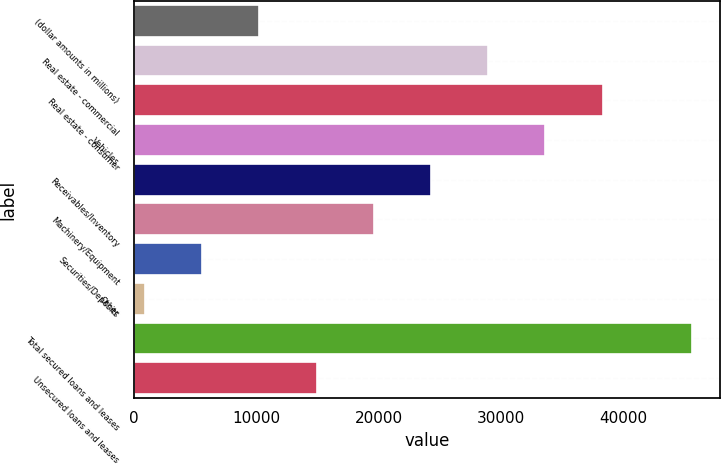Convert chart. <chart><loc_0><loc_0><loc_500><loc_500><bar_chart><fcel>(dollar amounts in millions)<fcel>Real estate - commercial<fcel>Real estate - consumer<fcel>Vehicles<fcel>Receivables/Inventory<fcel>Machinery/Equipment<fcel>Securities/Deposits<fcel>Other<fcel>Total secured loans and leases<fcel>Unsecured loans and leases<nl><fcel>10266.4<fcel>28961.2<fcel>38308.6<fcel>33634.9<fcel>24287.5<fcel>19613.8<fcel>5592.7<fcel>919<fcel>45599<fcel>14940.1<nl></chart> 